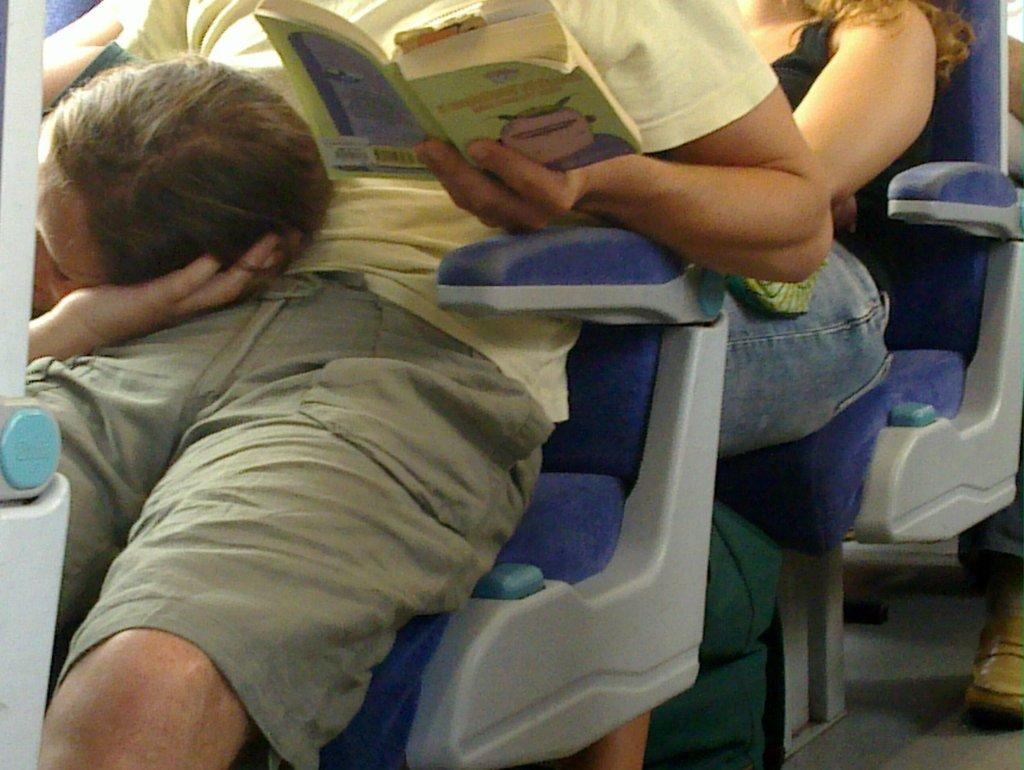What are the people in the image doing? There are people sitting in the seats, a man is holding a book, and a woman is lying on the man's lap. Can you describe the man's activity in the image? The man is holding a book. What is the woman's position in relation to the man? The woman is lying on the man's lap. What type of underwear is the woman wearing in the image? There is no information about the woman's underwear in the image, as it is not visible or mentioned in the provided facts. 